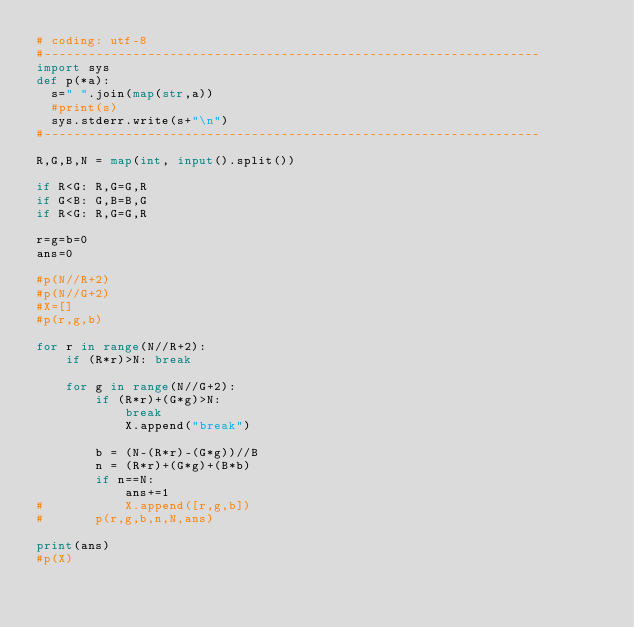<code> <loc_0><loc_0><loc_500><loc_500><_Python_># coding: utf-8
#-------------------------------------------------------------------
import sys
def p(*a):
  s=" ".join(map(str,a))
  #print(s)
  sys.stderr.write(s+"\n")
#-------------------------------------------------------------------

R,G,B,N = map(int, input().split())

if R<G: R,G=G,R
if G<B: G,B=B,G
if R<G: R,G=G,R

r=g=b=0
ans=0

#p(N//R+2)
#p(N//G+2)
#X=[]
#p(r,g,b)

for r in range(N//R+2):
	if (R*r)>N: break

	for g in range(N//G+2):
		if (R*r)+(G*g)>N:
			break
			X.append("break")
		
		b = (N-(R*r)-(G*g))//B
		n = (R*r)+(G*g)+(B*b)
		if n==N:
			ans+=1
#			X.append([r,g,b])
#		p(r,g,b,n,N,ans)

print(ans)
#p(X)
</code> 